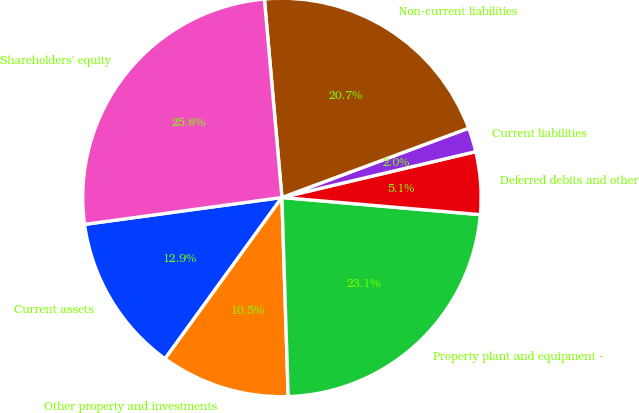Convert chart to OTSL. <chart><loc_0><loc_0><loc_500><loc_500><pie_chart><fcel>Current assets<fcel>Other property and investments<fcel>Property plant and equipment -<fcel>Deferred debits and other<fcel>Current liabilities<fcel>Non-current liabilities<fcel>Shareholders' equity<nl><fcel>12.86%<fcel>10.48%<fcel>23.12%<fcel>5.07%<fcel>1.96%<fcel>20.74%<fcel>25.75%<nl></chart> 